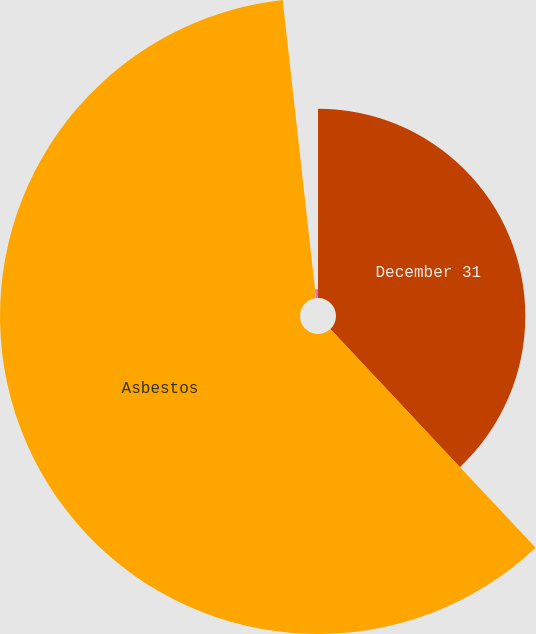Convert chart. <chart><loc_0><loc_0><loc_500><loc_500><pie_chart><fcel>December 31<fcel>Asbestos<fcel>Environmental<nl><fcel>38.0%<fcel>60.22%<fcel>1.77%<nl></chart> 